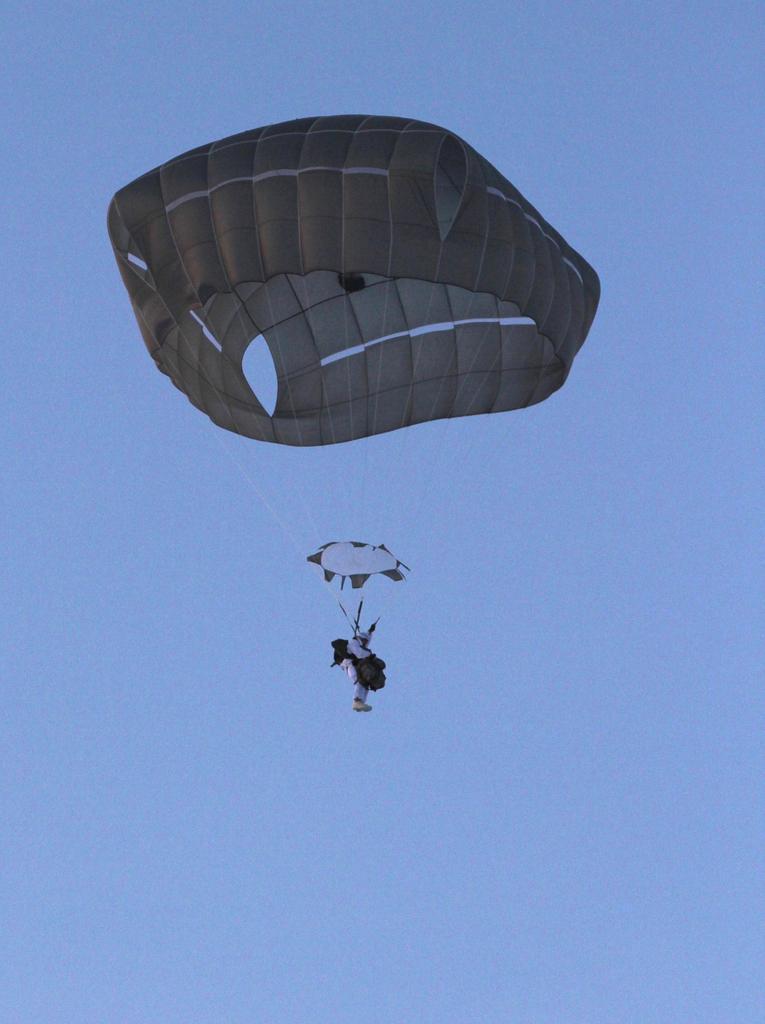How would you summarize this image in a sentence or two? In this picture there is a person flying with the parachute. At the top there is sky. 